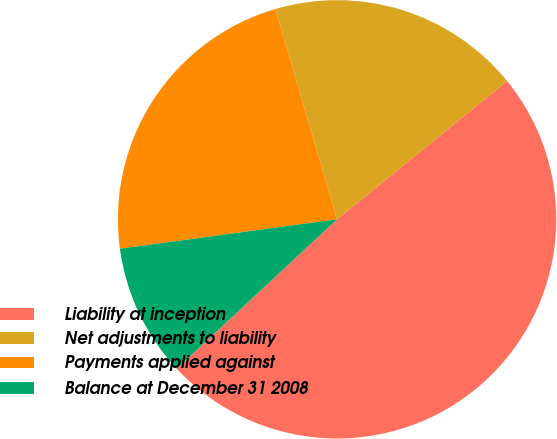<chart> <loc_0><loc_0><loc_500><loc_500><pie_chart><fcel>Liability at inception<fcel>Net adjustments to liability<fcel>Payments applied against<fcel>Balance at December 31 2008<nl><fcel>48.93%<fcel>18.68%<fcel>22.6%<fcel>9.79%<nl></chart> 